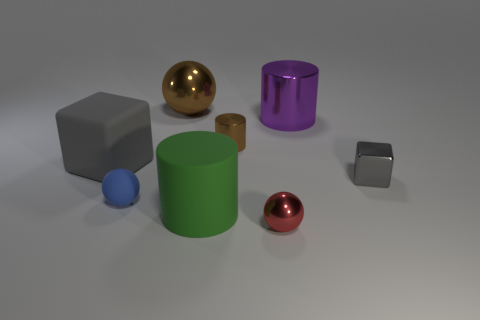There is a tiny shiny thing that is the same color as the big rubber cube; what is its shape?
Offer a very short reply. Cube. The gray thing that is the same size as the brown ball is what shape?
Your answer should be compact. Cube. There is a tiny cylinder; is it the same color as the large metallic thing to the left of the tiny red metallic object?
Make the answer very short. Yes. There is a shiny thing in front of the large rubber cylinder; what number of small gray metallic cubes are behind it?
Ensure brevity in your answer.  1. There is a ball that is both in front of the gray matte cube and to the right of the small rubber ball; how big is it?
Keep it short and to the point. Small. Is there another shiny thing of the same size as the purple thing?
Ensure brevity in your answer.  Yes. Is the number of small balls that are to the left of the green matte cylinder greater than the number of matte cubes that are to the right of the small brown cylinder?
Offer a terse response. Yes. Is the big block made of the same material as the large object in front of the tiny blue object?
Offer a very short reply. Yes. What number of cylinders are in front of the brown metal thing that is in front of the big metallic thing that is to the right of the big brown object?
Your answer should be very brief. 1. There is a large brown metal thing; does it have the same shape as the small object behind the tiny cube?
Provide a succinct answer. No. 